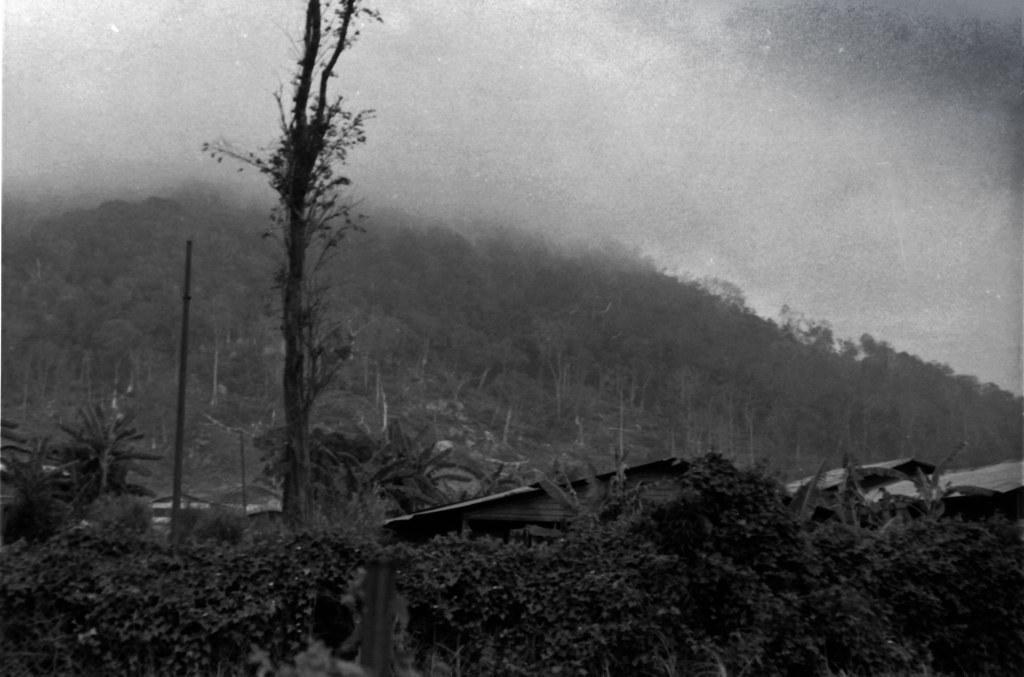Could you give a brief overview of what you see in this image? In this picture we can see trees, houses, poles, mountain and in the background we can see the sky. 